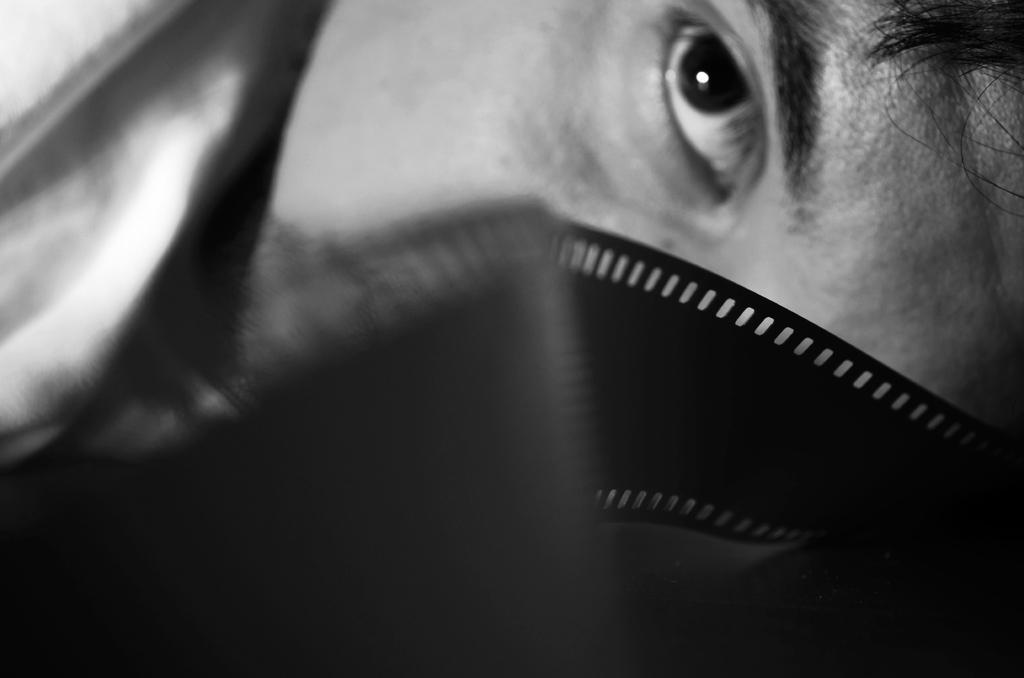What is the main subject of the image? The main subject of the image is a person's eye. What color scheme is used in the image? The image is in black and white. Can you see any signs of respect in the image? There is no indication of respect in the image, as it only features a person's eye in black and white. What type of sea creature can be seen swimming in the image? There is no sea creature present in the image, as it only features a person's eye in black and white. 